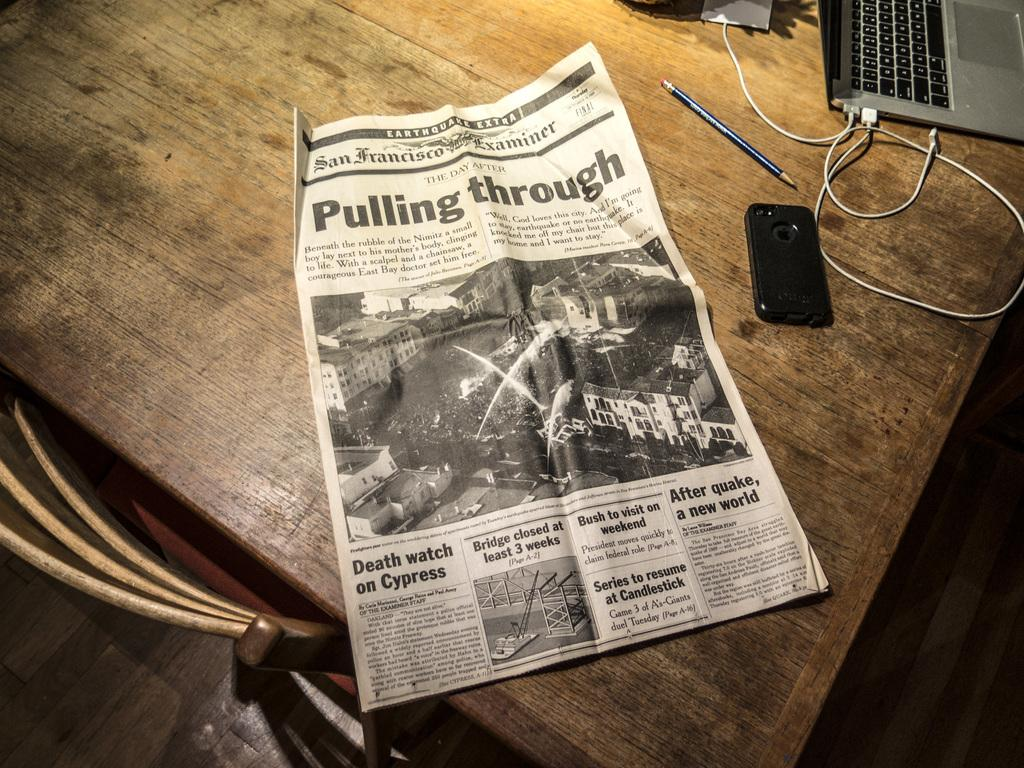<image>
Describe the image concisely. A copy of the San Francisco Examiner is sitting on a table. 